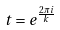Convert formula to latex. <formula><loc_0><loc_0><loc_500><loc_500>t = e ^ { \frac { 2 \pi i } { k } }</formula> 